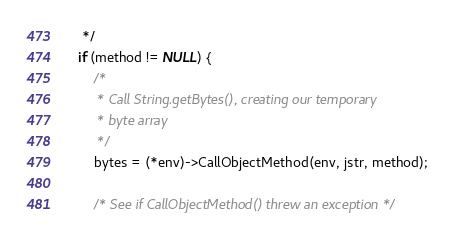Convert code to text. <code><loc_0><loc_0><loc_500><loc_500><_C_>	 */
	if (method != NULL) {
		/*
		 * Call String.getBytes(), creating our temporary
		 * byte array
		 */
		bytes = (*env)->CallObjectMethod(env, jstr, method);

		/* See if CallObjectMethod() threw an exception */</code> 